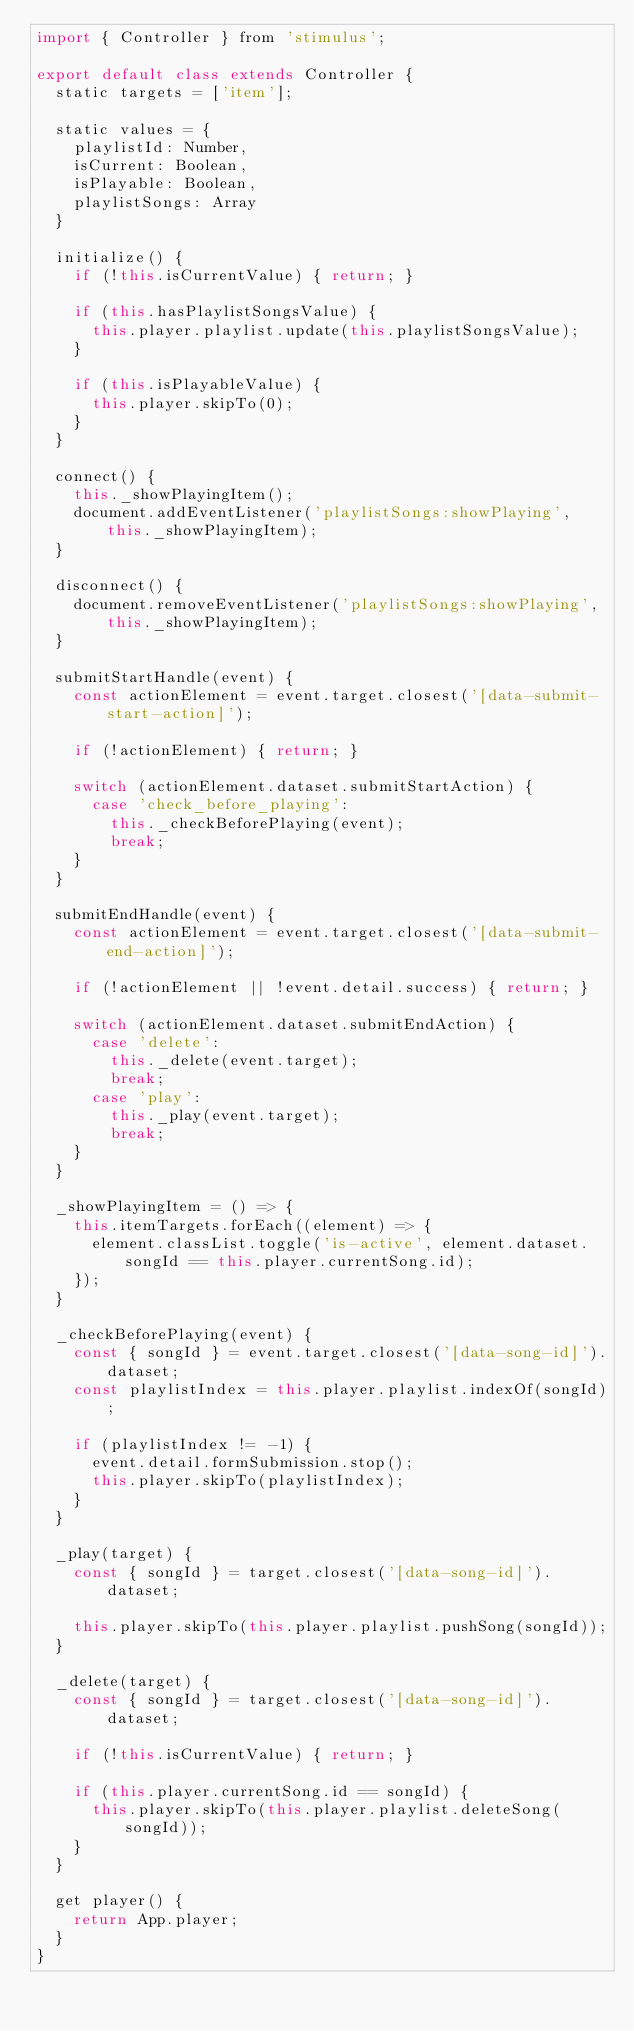Convert code to text. <code><loc_0><loc_0><loc_500><loc_500><_JavaScript_>import { Controller } from 'stimulus';

export default class extends Controller {
  static targets = ['item'];

  static values = {
    playlistId: Number,
    isCurrent: Boolean,
    isPlayable: Boolean,
    playlistSongs: Array
  }

  initialize() {
    if (!this.isCurrentValue) { return; }

    if (this.hasPlaylistSongsValue) {
      this.player.playlist.update(this.playlistSongsValue);
    }

    if (this.isPlayableValue) {
      this.player.skipTo(0);
    }
  }

  connect() {
    this._showPlayingItem();
    document.addEventListener('playlistSongs:showPlaying', this._showPlayingItem);
  }

  disconnect() {
    document.removeEventListener('playlistSongs:showPlaying', this._showPlayingItem);
  }

  submitStartHandle(event) {
    const actionElement = event.target.closest('[data-submit-start-action]');

    if (!actionElement) { return; }

    switch (actionElement.dataset.submitStartAction) {
      case 'check_before_playing':
        this._checkBeforePlaying(event);
        break;
    }
  }

  submitEndHandle(event) {
    const actionElement = event.target.closest('[data-submit-end-action]');

    if (!actionElement || !event.detail.success) { return; }

    switch (actionElement.dataset.submitEndAction) {
      case 'delete':
        this._delete(event.target);
        break;
      case 'play':
        this._play(event.target);
        break;
    }
  }

  _showPlayingItem = () => {
    this.itemTargets.forEach((element) => {
      element.classList.toggle('is-active', element.dataset.songId == this.player.currentSong.id);
    });
  }

  _checkBeforePlaying(event) {
    const { songId } = event.target.closest('[data-song-id]').dataset;
    const playlistIndex = this.player.playlist.indexOf(songId);

    if (playlistIndex != -1) {
      event.detail.formSubmission.stop();
      this.player.skipTo(playlistIndex);
    }
  }

  _play(target) {
    const { songId } = target.closest('[data-song-id]').dataset;

    this.player.skipTo(this.player.playlist.pushSong(songId));
  }

  _delete(target) {
    const { songId } = target.closest('[data-song-id]').dataset;

    if (!this.isCurrentValue) { return; }

    if (this.player.currentSong.id == songId) {
      this.player.skipTo(this.player.playlist.deleteSong(songId));
    }
  }

  get player() {
    return App.player;
  }
}
</code> 